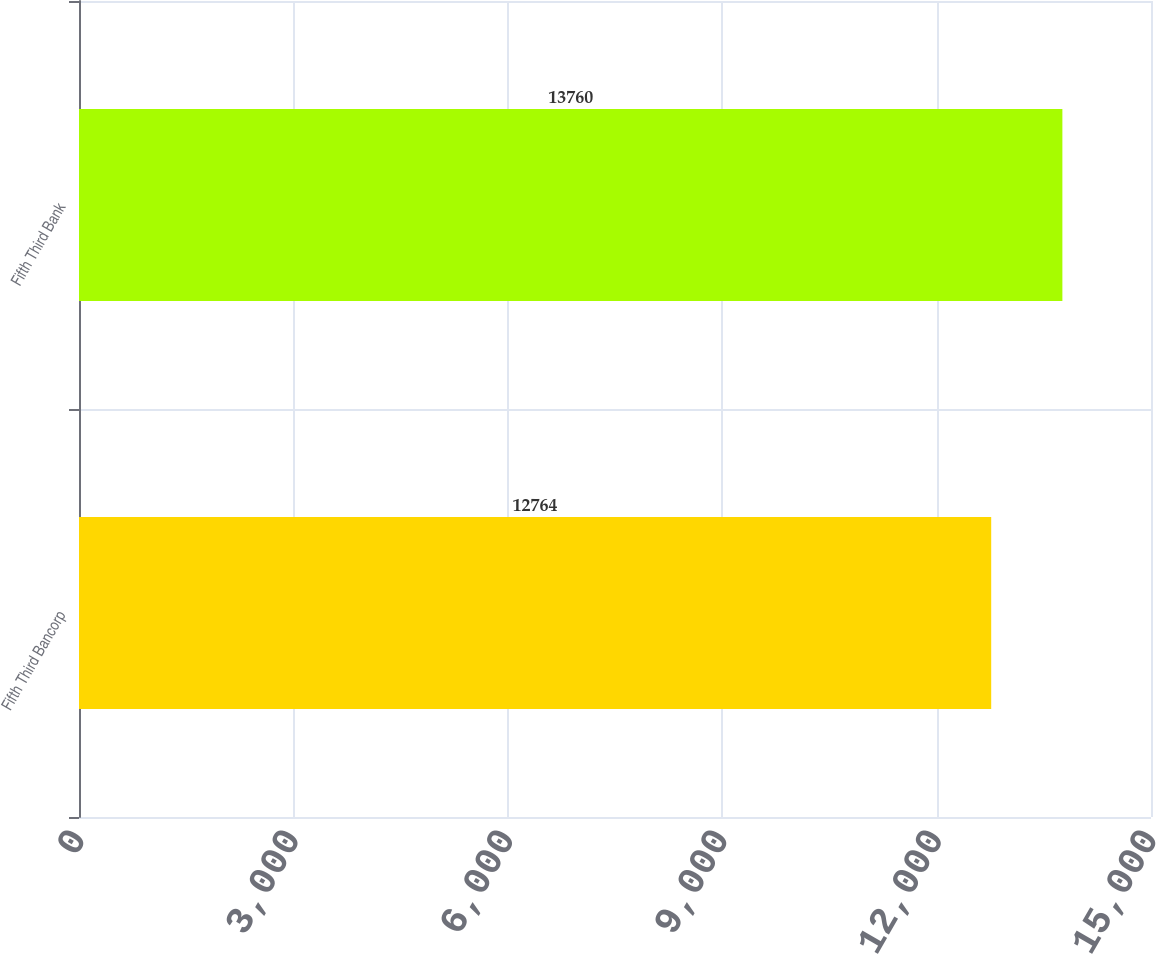Convert chart. <chart><loc_0><loc_0><loc_500><loc_500><bar_chart><fcel>Fifth Third Bancorp<fcel>Fifth Third Bank<nl><fcel>12764<fcel>13760<nl></chart> 